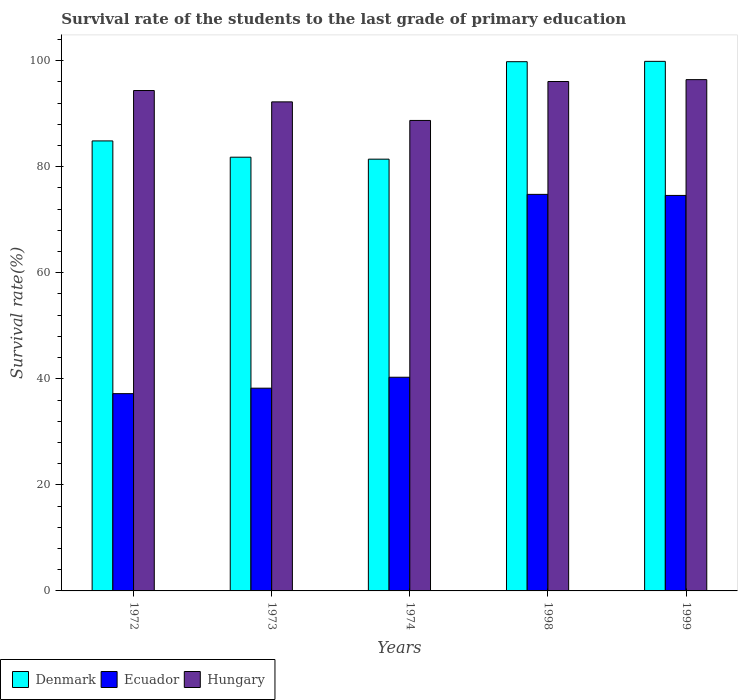How many different coloured bars are there?
Ensure brevity in your answer.  3. Are the number of bars on each tick of the X-axis equal?
Give a very brief answer. Yes. How many bars are there on the 5th tick from the left?
Keep it short and to the point. 3. What is the label of the 2nd group of bars from the left?
Your answer should be very brief. 1973. In how many cases, is the number of bars for a given year not equal to the number of legend labels?
Your answer should be very brief. 0. What is the survival rate of the students in Denmark in 1998?
Provide a short and direct response. 99.81. Across all years, what is the maximum survival rate of the students in Hungary?
Provide a succinct answer. 96.43. Across all years, what is the minimum survival rate of the students in Ecuador?
Keep it short and to the point. 37.21. In which year was the survival rate of the students in Hungary minimum?
Provide a short and direct response. 1974. What is the total survival rate of the students in Ecuador in the graph?
Give a very brief answer. 265.12. What is the difference between the survival rate of the students in Denmark in 1972 and that in 1999?
Ensure brevity in your answer.  -15. What is the difference between the survival rate of the students in Ecuador in 1998 and the survival rate of the students in Denmark in 1972?
Give a very brief answer. -10.08. What is the average survival rate of the students in Hungary per year?
Keep it short and to the point. 93.57. In the year 1973, what is the difference between the survival rate of the students in Denmark and survival rate of the students in Hungary?
Your answer should be very brief. -10.43. In how many years, is the survival rate of the students in Denmark greater than 20 %?
Make the answer very short. 5. What is the ratio of the survival rate of the students in Denmark in 1974 to that in 1999?
Make the answer very short. 0.82. Is the survival rate of the students in Denmark in 1972 less than that in 1998?
Provide a succinct answer. Yes. What is the difference between the highest and the second highest survival rate of the students in Ecuador?
Your response must be concise. 0.2. What is the difference between the highest and the lowest survival rate of the students in Hungary?
Make the answer very short. 7.7. Is the sum of the survival rate of the students in Denmark in 1972 and 1999 greater than the maximum survival rate of the students in Hungary across all years?
Your answer should be compact. Yes. What does the 3rd bar from the left in 1972 represents?
Your answer should be very brief. Hungary. How many years are there in the graph?
Provide a succinct answer. 5. What is the difference between two consecutive major ticks on the Y-axis?
Offer a terse response. 20. Are the values on the major ticks of Y-axis written in scientific E-notation?
Give a very brief answer. No. What is the title of the graph?
Offer a terse response. Survival rate of the students to the last grade of primary education. Does "Micronesia" appear as one of the legend labels in the graph?
Offer a very short reply. No. What is the label or title of the X-axis?
Keep it short and to the point. Years. What is the label or title of the Y-axis?
Offer a terse response. Survival rate(%). What is the Survival rate(%) of Denmark in 1972?
Keep it short and to the point. 84.87. What is the Survival rate(%) in Ecuador in 1972?
Offer a very short reply. 37.21. What is the Survival rate(%) of Hungary in 1972?
Offer a terse response. 94.38. What is the Survival rate(%) of Denmark in 1973?
Offer a terse response. 81.8. What is the Survival rate(%) of Ecuador in 1973?
Make the answer very short. 38.24. What is the Survival rate(%) of Hungary in 1973?
Your answer should be very brief. 92.23. What is the Survival rate(%) in Denmark in 1974?
Make the answer very short. 81.43. What is the Survival rate(%) of Ecuador in 1974?
Provide a succinct answer. 40.3. What is the Survival rate(%) in Hungary in 1974?
Provide a succinct answer. 88.73. What is the Survival rate(%) in Denmark in 1998?
Make the answer very short. 99.81. What is the Survival rate(%) of Ecuador in 1998?
Your response must be concise. 74.79. What is the Survival rate(%) in Hungary in 1998?
Your answer should be compact. 96.08. What is the Survival rate(%) of Denmark in 1999?
Your answer should be compact. 99.88. What is the Survival rate(%) in Ecuador in 1999?
Your answer should be compact. 74.59. What is the Survival rate(%) in Hungary in 1999?
Your response must be concise. 96.43. Across all years, what is the maximum Survival rate(%) of Denmark?
Your answer should be very brief. 99.88. Across all years, what is the maximum Survival rate(%) of Ecuador?
Keep it short and to the point. 74.79. Across all years, what is the maximum Survival rate(%) of Hungary?
Provide a succinct answer. 96.43. Across all years, what is the minimum Survival rate(%) in Denmark?
Make the answer very short. 81.43. Across all years, what is the minimum Survival rate(%) of Ecuador?
Ensure brevity in your answer.  37.21. Across all years, what is the minimum Survival rate(%) of Hungary?
Give a very brief answer. 88.73. What is the total Survival rate(%) in Denmark in the graph?
Provide a short and direct response. 447.79. What is the total Survival rate(%) of Ecuador in the graph?
Make the answer very short. 265.12. What is the total Survival rate(%) of Hungary in the graph?
Make the answer very short. 467.85. What is the difference between the Survival rate(%) in Denmark in 1972 and that in 1973?
Offer a very short reply. 3.07. What is the difference between the Survival rate(%) of Ecuador in 1972 and that in 1973?
Provide a succinct answer. -1.03. What is the difference between the Survival rate(%) of Hungary in 1972 and that in 1973?
Ensure brevity in your answer.  2.14. What is the difference between the Survival rate(%) in Denmark in 1972 and that in 1974?
Provide a succinct answer. 3.44. What is the difference between the Survival rate(%) in Ecuador in 1972 and that in 1974?
Offer a very short reply. -3.09. What is the difference between the Survival rate(%) of Hungary in 1972 and that in 1974?
Offer a terse response. 5.64. What is the difference between the Survival rate(%) in Denmark in 1972 and that in 1998?
Your answer should be compact. -14.94. What is the difference between the Survival rate(%) of Ecuador in 1972 and that in 1998?
Your response must be concise. -37.59. What is the difference between the Survival rate(%) in Hungary in 1972 and that in 1998?
Provide a short and direct response. -1.7. What is the difference between the Survival rate(%) in Denmark in 1972 and that in 1999?
Provide a short and direct response. -15. What is the difference between the Survival rate(%) in Ecuador in 1972 and that in 1999?
Offer a very short reply. -37.38. What is the difference between the Survival rate(%) of Hungary in 1972 and that in 1999?
Your answer should be very brief. -2.05. What is the difference between the Survival rate(%) in Denmark in 1973 and that in 1974?
Your answer should be very brief. 0.37. What is the difference between the Survival rate(%) of Ecuador in 1973 and that in 1974?
Your response must be concise. -2.06. What is the difference between the Survival rate(%) in Hungary in 1973 and that in 1974?
Make the answer very short. 3.5. What is the difference between the Survival rate(%) in Denmark in 1973 and that in 1998?
Your response must be concise. -18.01. What is the difference between the Survival rate(%) in Ecuador in 1973 and that in 1998?
Provide a short and direct response. -36.55. What is the difference between the Survival rate(%) of Hungary in 1973 and that in 1998?
Provide a short and direct response. -3.84. What is the difference between the Survival rate(%) in Denmark in 1973 and that in 1999?
Keep it short and to the point. -18.08. What is the difference between the Survival rate(%) of Ecuador in 1973 and that in 1999?
Provide a short and direct response. -36.35. What is the difference between the Survival rate(%) of Hungary in 1973 and that in 1999?
Provide a short and direct response. -4.2. What is the difference between the Survival rate(%) in Denmark in 1974 and that in 1998?
Keep it short and to the point. -18.38. What is the difference between the Survival rate(%) in Ecuador in 1974 and that in 1998?
Keep it short and to the point. -34.49. What is the difference between the Survival rate(%) in Hungary in 1974 and that in 1998?
Offer a terse response. -7.34. What is the difference between the Survival rate(%) in Denmark in 1974 and that in 1999?
Make the answer very short. -18.45. What is the difference between the Survival rate(%) in Ecuador in 1974 and that in 1999?
Your response must be concise. -34.29. What is the difference between the Survival rate(%) of Hungary in 1974 and that in 1999?
Offer a terse response. -7.7. What is the difference between the Survival rate(%) in Denmark in 1998 and that in 1999?
Your answer should be very brief. -0.06. What is the difference between the Survival rate(%) in Ecuador in 1998 and that in 1999?
Your answer should be compact. 0.2. What is the difference between the Survival rate(%) in Hungary in 1998 and that in 1999?
Provide a succinct answer. -0.35. What is the difference between the Survival rate(%) in Denmark in 1972 and the Survival rate(%) in Ecuador in 1973?
Give a very brief answer. 46.63. What is the difference between the Survival rate(%) of Denmark in 1972 and the Survival rate(%) of Hungary in 1973?
Provide a succinct answer. -7.36. What is the difference between the Survival rate(%) of Ecuador in 1972 and the Survival rate(%) of Hungary in 1973?
Offer a terse response. -55.03. What is the difference between the Survival rate(%) of Denmark in 1972 and the Survival rate(%) of Ecuador in 1974?
Make the answer very short. 44.57. What is the difference between the Survival rate(%) in Denmark in 1972 and the Survival rate(%) in Hungary in 1974?
Your answer should be compact. -3.86. What is the difference between the Survival rate(%) of Ecuador in 1972 and the Survival rate(%) of Hungary in 1974?
Ensure brevity in your answer.  -51.53. What is the difference between the Survival rate(%) of Denmark in 1972 and the Survival rate(%) of Ecuador in 1998?
Your answer should be very brief. 10.08. What is the difference between the Survival rate(%) in Denmark in 1972 and the Survival rate(%) in Hungary in 1998?
Your answer should be compact. -11.2. What is the difference between the Survival rate(%) in Ecuador in 1972 and the Survival rate(%) in Hungary in 1998?
Provide a succinct answer. -58.87. What is the difference between the Survival rate(%) in Denmark in 1972 and the Survival rate(%) in Ecuador in 1999?
Your response must be concise. 10.28. What is the difference between the Survival rate(%) in Denmark in 1972 and the Survival rate(%) in Hungary in 1999?
Your answer should be compact. -11.56. What is the difference between the Survival rate(%) of Ecuador in 1972 and the Survival rate(%) of Hungary in 1999?
Provide a succinct answer. -59.22. What is the difference between the Survival rate(%) in Denmark in 1973 and the Survival rate(%) in Ecuador in 1974?
Your response must be concise. 41.5. What is the difference between the Survival rate(%) in Denmark in 1973 and the Survival rate(%) in Hungary in 1974?
Ensure brevity in your answer.  -6.93. What is the difference between the Survival rate(%) in Ecuador in 1973 and the Survival rate(%) in Hungary in 1974?
Provide a succinct answer. -50.49. What is the difference between the Survival rate(%) of Denmark in 1973 and the Survival rate(%) of Ecuador in 1998?
Make the answer very short. 7.01. What is the difference between the Survival rate(%) in Denmark in 1973 and the Survival rate(%) in Hungary in 1998?
Offer a very short reply. -14.28. What is the difference between the Survival rate(%) of Ecuador in 1973 and the Survival rate(%) of Hungary in 1998?
Ensure brevity in your answer.  -57.84. What is the difference between the Survival rate(%) in Denmark in 1973 and the Survival rate(%) in Ecuador in 1999?
Ensure brevity in your answer.  7.21. What is the difference between the Survival rate(%) of Denmark in 1973 and the Survival rate(%) of Hungary in 1999?
Provide a succinct answer. -14.63. What is the difference between the Survival rate(%) in Ecuador in 1973 and the Survival rate(%) in Hungary in 1999?
Make the answer very short. -58.19. What is the difference between the Survival rate(%) of Denmark in 1974 and the Survival rate(%) of Ecuador in 1998?
Provide a succinct answer. 6.64. What is the difference between the Survival rate(%) in Denmark in 1974 and the Survival rate(%) in Hungary in 1998?
Keep it short and to the point. -14.65. What is the difference between the Survival rate(%) of Ecuador in 1974 and the Survival rate(%) of Hungary in 1998?
Ensure brevity in your answer.  -55.78. What is the difference between the Survival rate(%) of Denmark in 1974 and the Survival rate(%) of Ecuador in 1999?
Provide a short and direct response. 6.84. What is the difference between the Survival rate(%) of Denmark in 1974 and the Survival rate(%) of Hungary in 1999?
Provide a succinct answer. -15. What is the difference between the Survival rate(%) of Ecuador in 1974 and the Survival rate(%) of Hungary in 1999?
Provide a short and direct response. -56.13. What is the difference between the Survival rate(%) in Denmark in 1998 and the Survival rate(%) in Ecuador in 1999?
Offer a very short reply. 25.22. What is the difference between the Survival rate(%) of Denmark in 1998 and the Survival rate(%) of Hungary in 1999?
Keep it short and to the point. 3.38. What is the difference between the Survival rate(%) of Ecuador in 1998 and the Survival rate(%) of Hungary in 1999?
Give a very brief answer. -21.64. What is the average Survival rate(%) in Denmark per year?
Your response must be concise. 89.56. What is the average Survival rate(%) of Ecuador per year?
Make the answer very short. 53.02. What is the average Survival rate(%) in Hungary per year?
Offer a terse response. 93.57. In the year 1972, what is the difference between the Survival rate(%) of Denmark and Survival rate(%) of Ecuador?
Offer a very short reply. 47.67. In the year 1972, what is the difference between the Survival rate(%) in Denmark and Survival rate(%) in Hungary?
Offer a terse response. -9.5. In the year 1972, what is the difference between the Survival rate(%) in Ecuador and Survival rate(%) in Hungary?
Give a very brief answer. -57.17. In the year 1973, what is the difference between the Survival rate(%) in Denmark and Survival rate(%) in Ecuador?
Provide a short and direct response. 43.56. In the year 1973, what is the difference between the Survival rate(%) in Denmark and Survival rate(%) in Hungary?
Give a very brief answer. -10.43. In the year 1973, what is the difference between the Survival rate(%) in Ecuador and Survival rate(%) in Hungary?
Offer a terse response. -54. In the year 1974, what is the difference between the Survival rate(%) of Denmark and Survival rate(%) of Ecuador?
Your answer should be very brief. 41.13. In the year 1974, what is the difference between the Survival rate(%) in Denmark and Survival rate(%) in Hungary?
Give a very brief answer. -7.3. In the year 1974, what is the difference between the Survival rate(%) of Ecuador and Survival rate(%) of Hungary?
Provide a short and direct response. -48.43. In the year 1998, what is the difference between the Survival rate(%) in Denmark and Survival rate(%) in Ecuador?
Offer a terse response. 25.02. In the year 1998, what is the difference between the Survival rate(%) in Denmark and Survival rate(%) in Hungary?
Your answer should be compact. 3.74. In the year 1998, what is the difference between the Survival rate(%) of Ecuador and Survival rate(%) of Hungary?
Make the answer very short. -21.28. In the year 1999, what is the difference between the Survival rate(%) in Denmark and Survival rate(%) in Ecuador?
Offer a very short reply. 25.29. In the year 1999, what is the difference between the Survival rate(%) of Denmark and Survival rate(%) of Hungary?
Your answer should be very brief. 3.45. In the year 1999, what is the difference between the Survival rate(%) in Ecuador and Survival rate(%) in Hungary?
Keep it short and to the point. -21.84. What is the ratio of the Survival rate(%) in Denmark in 1972 to that in 1973?
Provide a short and direct response. 1.04. What is the ratio of the Survival rate(%) in Hungary in 1972 to that in 1973?
Give a very brief answer. 1.02. What is the ratio of the Survival rate(%) in Denmark in 1972 to that in 1974?
Your answer should be compact. 1.04. What is the ratio of the Survival rate(%) in Ecuador in 1972 to that in 1974?
Make the answer very short. 0.92. What is the ratio of the Survival rate(%) of Hungary in 1972 to that in 1974?
Ensure brevity in your answer.  1.06. What is the ratio of the Survival rate(%) in Denmark in 1972 to that in 1998?
Keep it short and to the point. 0.85. What is the ratio of the Survival rate(%) of Ecuador in 1972 to that in 1998?
Offer a terse response. 0.5. What is the ratio of the Survival rate(%) in Hungary in 1972 to that in 1998?
Offer a terse response. 0.98. What is the ratio of the Survival rate(%) of Denmark in 1972 to that in 1999?
Your response must be concise. 0.85. What is the ratio of the Survival rate(%) in Ecuador in 1972 to that in 1999?
Make the answer very short. 0.5. What is the ratio of the Survival rate(%) in Hungary in 1972 to that in 1999?
Offer a terse response. 0.98. What is the ratio of the Survival rate(%) in Ecuador in 1973 to that in 1974?
Ensure brevity in your answer.  0.95. What is the ratio of the Survival rate(%) in Hungary in 1973 to that in 1974?
Provide a short and direct response. 1.04. What is the ratio of the Survival rate(%) of Denmark in 1973 to that in 1998?
Give a very brief answer. 0.82. What is the ratio of the Survival rate(%) in Ecuador in 1973 to that in 1998?
Provide a short and direct response. 0.51. What is the ratio of the Survival rate(%) in Denmark in 1973 to that in 1999?
Your answer should be very brief. 0.82. What is the ratio of the Survival rate(%) in Ecuador in 1973 to that in 1999?
Offer a very short reply. 0.51. What is the ratio of the Survival rate(%) of Hungary in 1973 to that in 1999?
Offer a very short reply. 0.96. What is the ratio of the Survival rate(%) of Denmark in 1974 to that in 1998?
Offer a very short reply. 0.82. What is the ratio of the Survival rate(%) in Ecuador in 1974 to that in 1998?
Keep it short and to the point. 0.54. What is the ratio of the Survival rate(%) in Hungary in 1974 to that in 1998?
Give a very brief answer. 0.92. What is the ratio of the Survival rate(%) in Denmark in 1974 to that in 1999?
Give a very brief answer. 0.82. What is the ratio of the Survival rate(%) in Ecuador in 1974 to that in 1999?
Provide a succinct answer. 0.54. What is the ratio of the Survival rate(%) of Hungary in 1974 to that in 1999?
Make the answer very short. 0.92. What is the ratio of the Survival rate(%) of Ecuador in 1998 to that in 1999?
Give a very brief answer. 1. What is the difference between the highest and the second highest Survival rate(%) in Denmark?
Your response must be concise. 0.06. What is the difference between the highest and the second highest Survival rate(%) of Ecuador?
Provide a short and direct response. 0.2. What is the difference between the highest and the second highest Survival rate(%) in Hungary?
Offer a very short reply. 0.35. What is the difference between the highest and the lowest Survival rate(%) in Denmark?
Your answer should be very brief. 18.45. What is the difference between the highest and the lowest Survival rate(%) in Ecuador?
Provide a succinct answer. 37.59. What is the difference between the highest and the lowest Survival rate(%) in Hungary?
Ensure brevity in your answer.  7.7. 